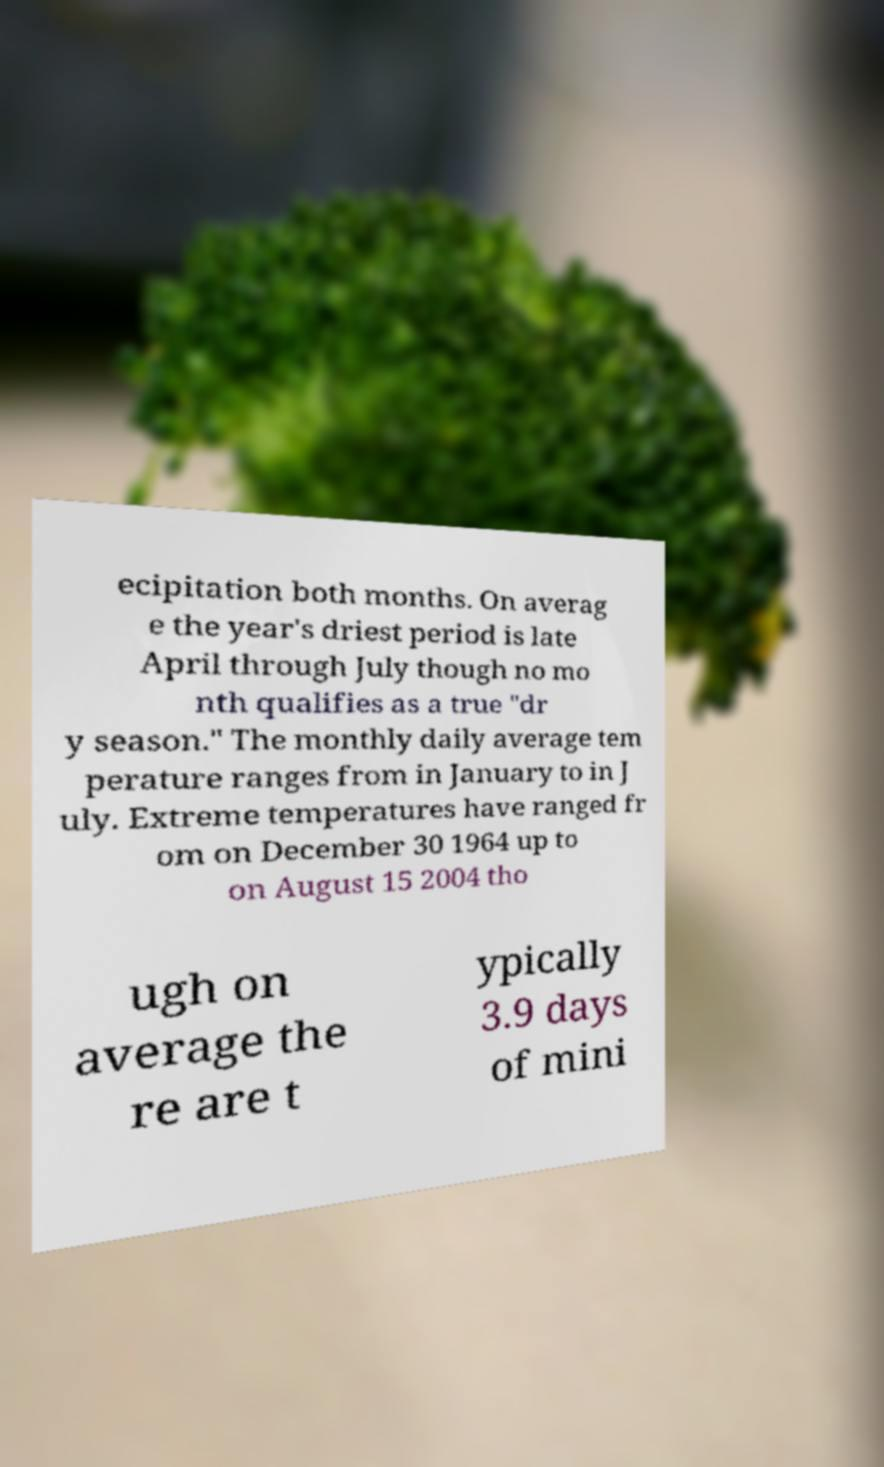Can you read and provide the text displayed in the image?This photo seems to have some interesting text. Can you extract and type it out for me? ecipitation both months. On averag e the year's driest period is late April through July though no mo nth qualifies as a true "dr y season." The monthly daily average tem perature ranges from in January to in J uly. Extreme temperatures have ranged fr om on December 30 1964 up to on August 15 2004 tho ugh on average the re are t ypically 3.9 days of mini 